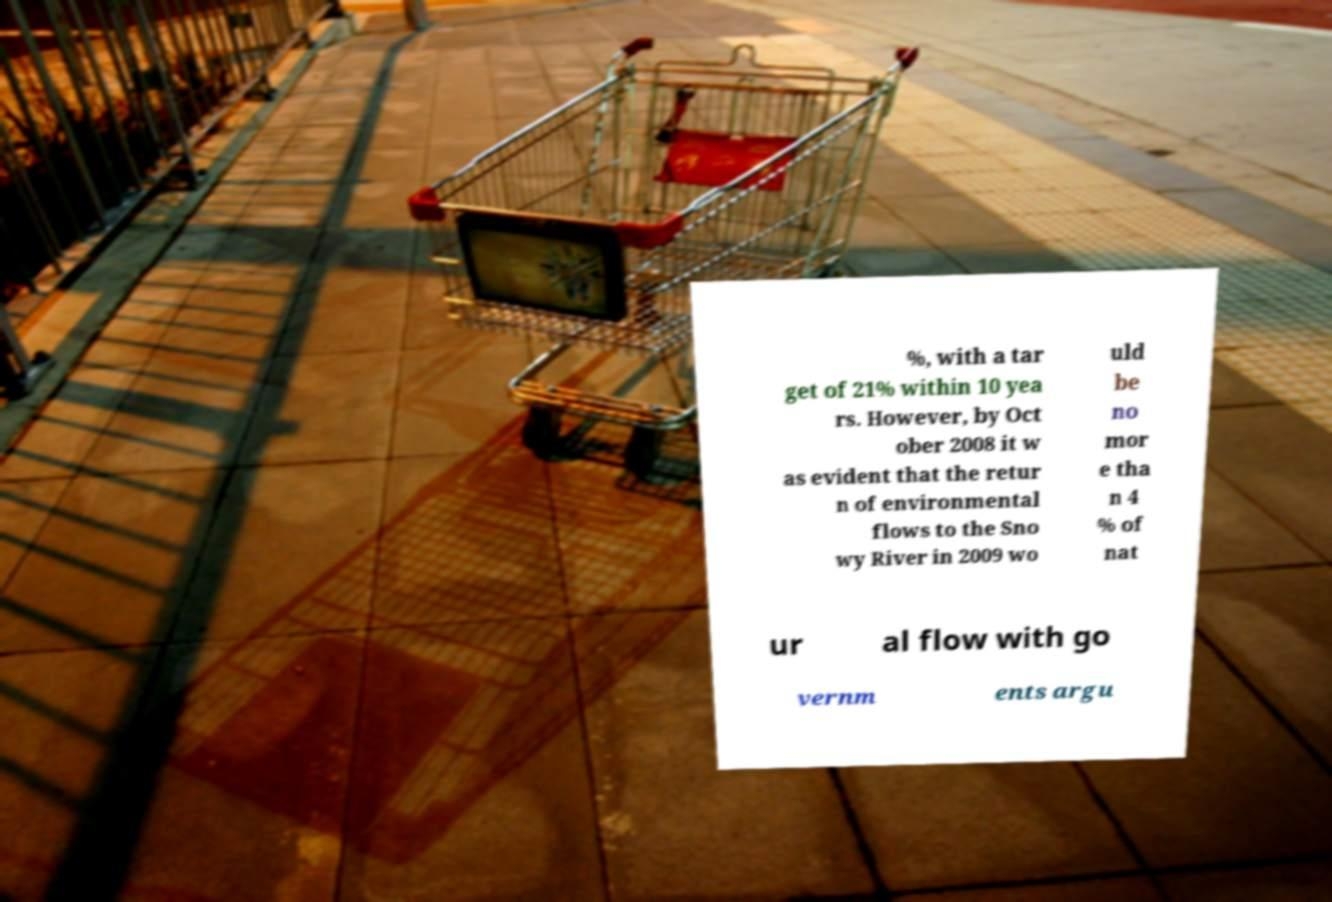Can you accurately transcribe the text from the provided image for me? %, with a tar get of 21% within 10 yea rs. However, by Oct ober 2008 it w as evident that the retur n of environmental flows to the Sno wy River in 2009 wo uld be no mor e tha n 4 % of nat ur al flow with go vernm ents argu 